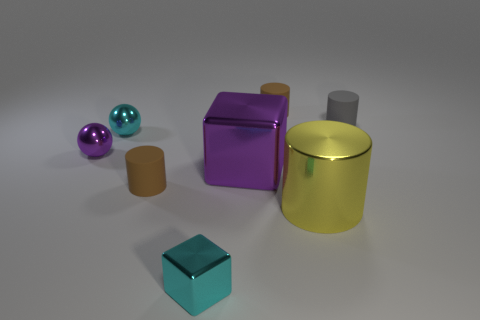There is a big cube; is its color the same as the sphere in front of the cyan metallic ball?
Your answer should be compact. Yes. What color is the matte cylinder that is in front of the large purple metal thing that is in front of the purple object that is to the left of the large purple metal thing?
Your response must be concise. Brown. How many other objects are there of the same color as the small cube?
Keep it short and to the point. 1. Is the number of large purple objects less than the number of big objects?
Your response must be concise. Yes. There is a small object that is both on the left side of the purple metallic cube and behind the purple metal ball; what is its color?
Keep it short and to the point. Cyan. What is the material of the tiny gray thing that is the same shape as the yellow thing?
Provide a succinct answer. Rubber. Are there any other things that have the same size as the purple ball?
Offer a very short reply. Yes. Are there more big metal things than purple metal cubes?
Your answer should be very brief. Yes. There is a cylinder that is in front of the tiny cyan sphere and behind the large yellow shiny object; what is its size?
Provide a short and direct response. Small. There is a tiny purple metal object; what shape is it?
Offer a very short reply. Sphere. 